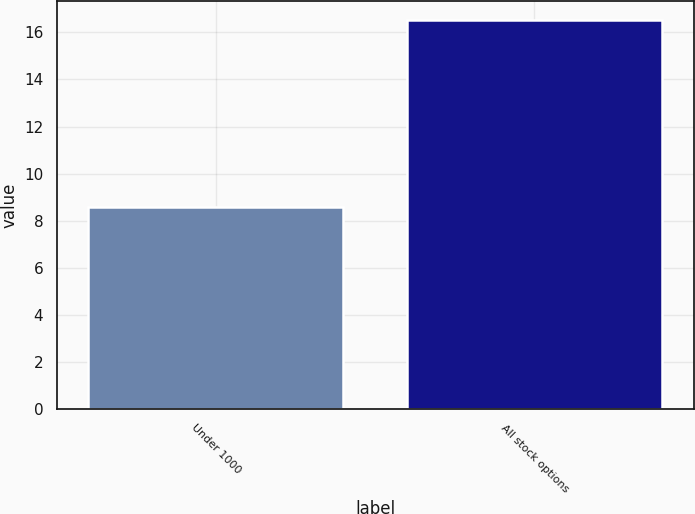Convert chart to OTSL. <chart><loc_0><loc_0><loc_500><loc_500><bar_chart><fcel>Under 1000<fcel>All stock options<nl><fcel>8.59<fcel>16.5<nl></chart> 